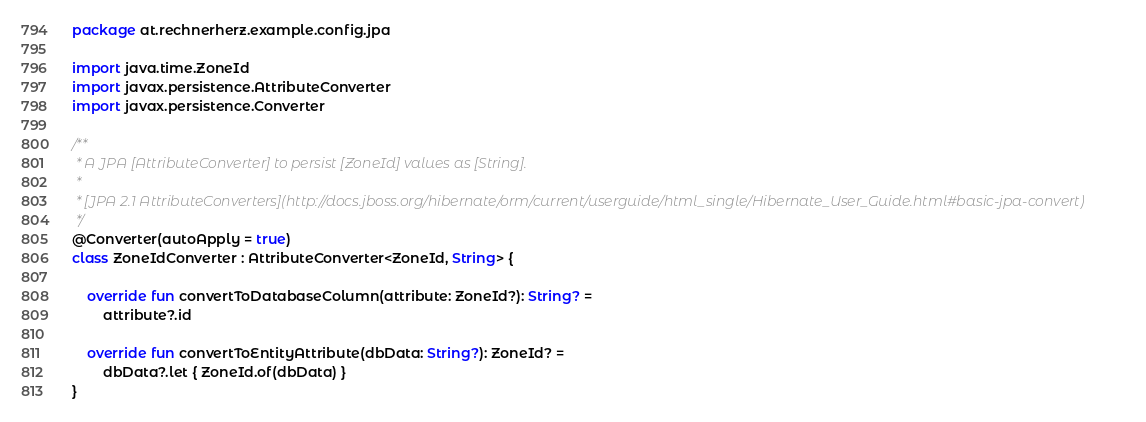Convert code to text. <code><loc_0><loc_0><loc_500><loc_500><_Kotlin_>package at.rechnerherz.example.config.jpa

import java.time.ZoneId
import javax.persistence.AttributeConverter
import javax.persistence.Converter

/**
 * A JPA [AttributeConverter] to persist [ZoneId] values as [String].
 *
 * [JPA 2.1 AttributeConverters](http://docs.jboss.org/hibernate/orm/current/userguide/html_single/Hibernate_User_Guide.html#basic-jpa-convert)
 */
@Converter(autoApply = true)
class ZoneIdConverter : AttributeConverter<ZoneId, String> {

    override fun convertToDatabaseColumn(attribute: ZoneId?): String? =
        attribute?.id

    override fun convertToEntityAttribute(dbData: String?): ZoneId? =
        dbData?.let { ZoneId.of(dbData) }
}
</code> 